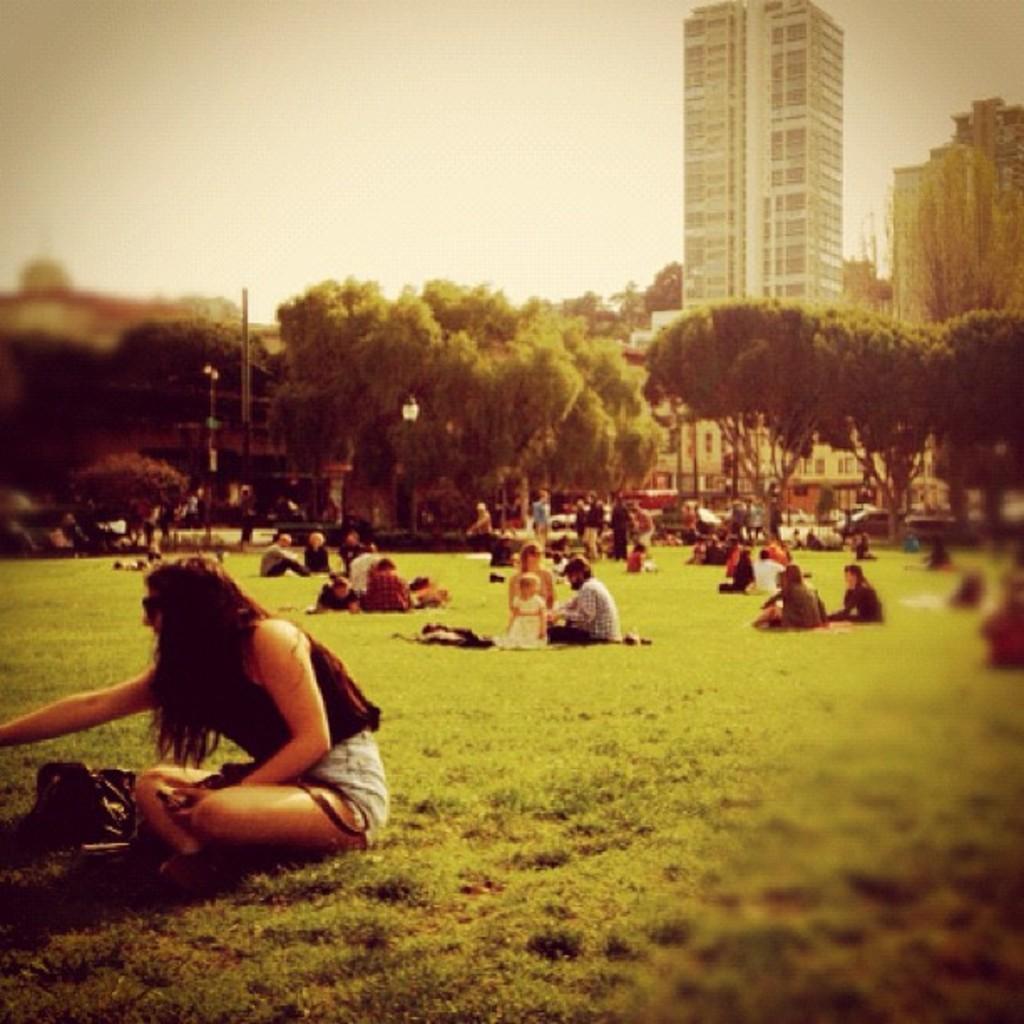Can you describe this image briefly? In this picture we can see there some people are sitting and some people are standing on the grass path. Behind the people there are poles, trees, buildings and the sky. On the path there are some vehicles. 